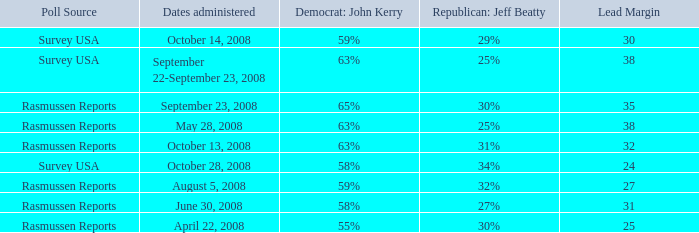What is the percentage for john kerry and dates administered is april 22, 2008? 55%. 